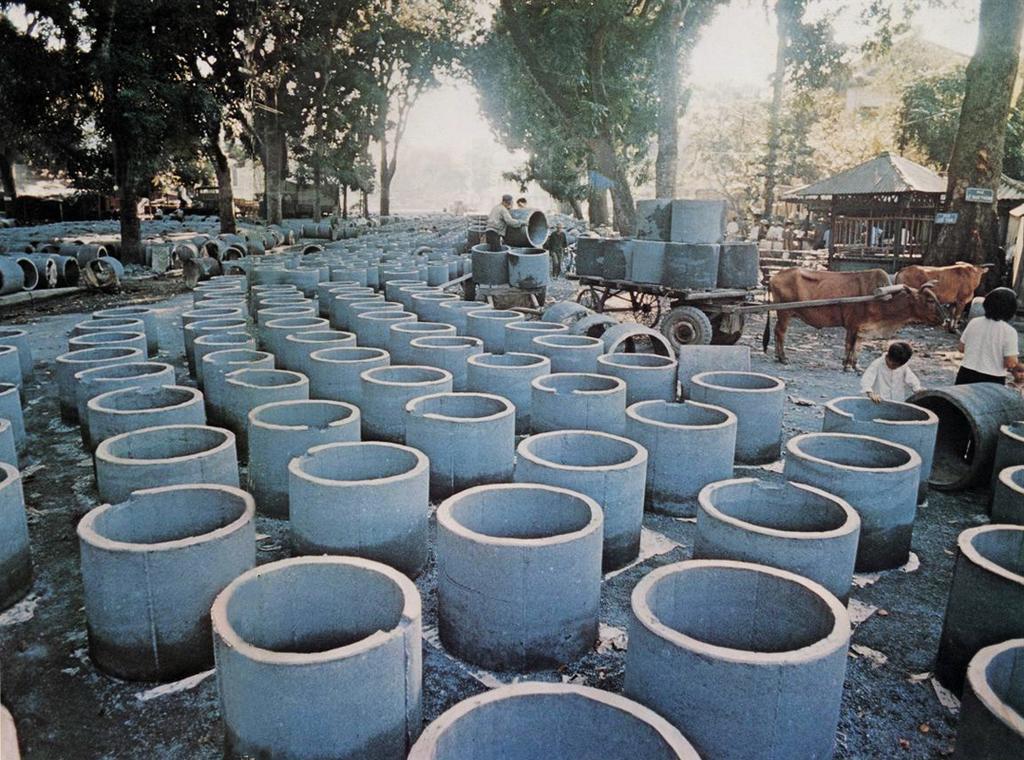In one or two sentences, can you explain what this image depicts? This is an outside view. In this image, I can see many concrete well rings on the ground. On the right side there are few people standing and there is a cart on which few concrete well rings are placed. In the background there is a shed. at the top of the image there are many trees. 